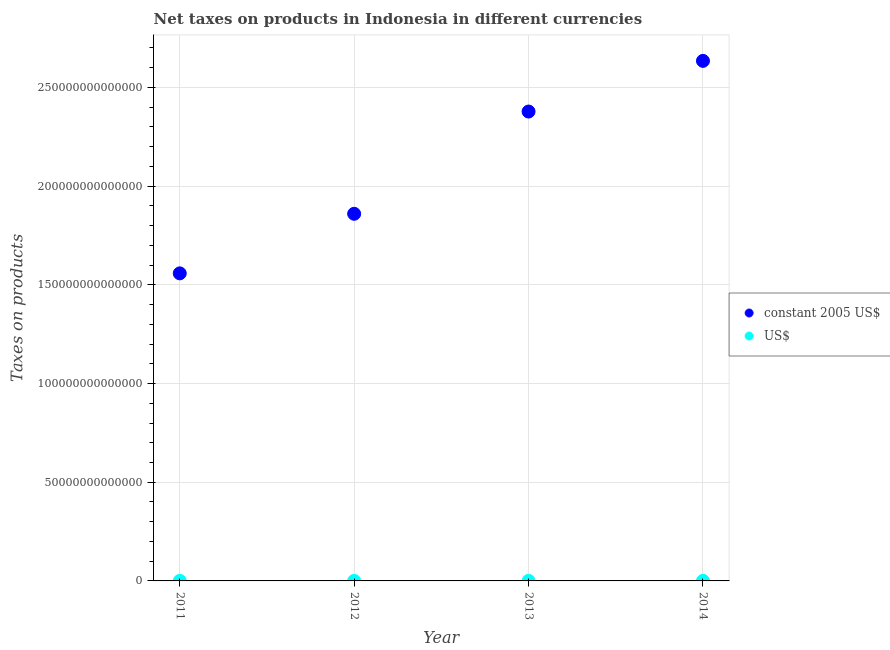How many different coloured dotlines are there?
Your answer should be very brief. 2. What is the net taxes in us$ in 2012?
Provide a short and direct response. 1.98e+1. Across all years, what is the maximum net taxes in constant 2005 us$?
Offer a very short reply. 2.63e+14. Across all years, what is the minimum net taxes in constant 2005 us$?
Give a very brief answer. 1.56e+14. In which year was the net taxes in us$ maximum?
Make the answer very short. 2013. What is the total net taxes in constant 2005 us$ in the graph?
Give a very brief answer. 8.43e+14. What is the difference between the net taxes in us$ in 2013 and that in 2014?
Provide a succinct answer. 5.26e+08. What is the difference between the net taxes in constant 2005 us$ in 2014 and the net taxes in us$ in 2012?
Give a very brief answer. 2.63e+14. What is the average net taxes in us$ per year?
Make the answer very short. 2.06e+1. In the year 2012, what is the difference between the net taxes in us$ and net taxes in constant 2005 us$?
Ensure brevity in your answer.  -1.86e+14. In how many years, is the net taxes in constant 2005 us$ greater than 40000000000000 units?
Ensure brevity in your answer.  4. What is the ratio of the net taxes in us$ in 2013 to that in 2014?
Your response must be concise. 1.02. Is the difference between the net taxes in us$ in 2011 and 2013 greater than the difference between the net taxes in constant 2005 us$ in 2011 and 2013?
Keep it short and to the point. Yes. What is the difference between the highest and the second highest net taxes in constant 2005 us$?
Provide a short and direct response. 2.57e+13. What is the difference between the highest and the lowest net taxes in constant 2005 us$?
Your answer should be compact. 1.08e+14. In how many years, is the net taxes in constant 2005 us$ greater than the average net taxes in constant 2005 us$ taken over all years?
Your response must be concise. 2. Is the net taxes in us$ strictly greater than the net taxes in constant 2005 us$ over the years?
Ensure brevity in your answer.  No. How many dotlines are there?
Your answer should be compact. 2. What is the difference between two consecutive major ticks on the Y-axis?
Your answer should be compact. 5.00e+13. Are the values on the major ticks of Y-axis written in scientific E-notation?
Your response must be concise. No. Does the graph contain any zero values?
Make the answer very short. No. Where does the legend appear in the graph?
Give a very brief answer. Center right. How many legend labels are there?
Give a very brief answer. 2. What is the title of the graph?
Your answer should be very brief. Net taxes on products in Indonesia in different currencies. Does "Arms exports" appear as one of the legend labels in the graph?
Offer a very short reply. No. What is the label or title of the Y-axis?
Your response must be concise. Taxes on products. What is the Taxes on products in constant 2005 US$ in 2011?
Provide a short and direct response. 1.56e+14. What is the Taxes on products of US$ in 2011?
Your answer should be compact. 1.78e+1. What is the Taxes on products of constant 2005 US$ in 2012?
Offer a very short reply. 1.86e+14. What is the Taxes on products in US$ in 2012?
Your response must be concise. 1.98e+1. What is the Taxes on products in constant 2005 US$ in 2013?
Keep it short and to the point. 2.38e+14. What is the Taxes on products in US$ in 2013?
Provide a succinct answer. 2.27e+1. What is the Taxes on products of constant 2005 US$ in 2014?
Keep it short and to the point. 2.63e+14. What is the Taxes on products in US$ in 2014?
Provide a succinct answer. 2.22e+1. Across all years, what is the maximum Taxes on products of constant 2005 US$?
Your answer should be very brief. 2.63e+14. Across all years, what is the maximum Taxes on products in US$?
Offer a very short reply. 2.27e+1. Across all years, what is the minimum Taxes on products of constant 2005 US$?
Ensure brevity in your answer.  1.56e+14. Across all years, what is the minimum Taxes on products in US$?
Your answer should be compact. 1.78e+1. What is the total Taxes on products in constant 2005 US$ in the graph?
Provide a short and direct response. 8.43e+14. What is the total Taxes on products of US$ in the graph?
Provide a short and direct response. 8.25e+1. What is the difference between the Taxes on products of constant 2005 US$ in 2011 and that in 2012?
Provide a short and direct response. -3.02e+13. What is the difference between the Taxes on products in US$ in 2011 and that in 2012?
Ensure brevity in your answer.  -2.05e+09. What is the difference between the Taxes on products of constant 2005 US$ in 2011 and that in 2013?
Your response must be concise. -8.20e+13. What is the difference between the Taxes on products in US$ in 2011 and that in 2013?
Ensure brevity in your answer.  -4.96e+09. What is the difference between the Taxes on products of constant 2005 US$ in 2011 and that in 2014?
Your answer should be compact. -1.08e+14. What is the difference between the Taxes on products in US$ in 2011 and that in 2014?
Your answer should be compact. -4.44e+09. What is the difference between the Taxes on products of constant 2005 US$ in 2012 and that in 2013?
Make the answer very short. -5.18e+13. What is the difference between the Taxes on products of US$ in 2012 and that in 2013?
Give a very brief answer. -2.92e+09. What is the difference between the Taxes on products of constant 2005 US$ in 2012 and that in 2014?
Ensure brevity in your answer.  -7.75e+13. What is the difference between the Taxes on products of US$ in 2012 and that in 2014?
Your response must be concise. -2.39e+09. What is the difference between the Taxes on products of constant 2005 US$ in 2013 and that in 2014?
Give a very brief answer. -2.57e+13. What is the difference between the Taxes on products in US$ in 2013 and that in 2014?
Your response must be concise. 5.26e+08. What is the difference between the Taxes on products in constant 2005 US$ in 2011 and the Taxes on products in US$ in 2012?
Provide a short and direct response. 1.56e+14. What is the difference between the Taxes on products of constant 2005 US$ in 2011 and the Taxes on products of US$ in 2013?
Keep it short and to the point. 1.56e+14. What is the difference between the Taxes on products of constant 2005 US$ in 2011 and the Taxes on products of US$ in 2014?
Provide a succinct answer. 1.56e+14. What is the difference between the Taxes on products in constant 2005 US$ in 2012 and the Taxes on products in US$ in 2013?
Your response must be concise. 1.86e+14. What is the difference between the Taxes on products in constant 2005 US$ in 2012 and the Taxes on products in US$ in 2014?
Your answer should be compact. 1.86e+14. What is the difference between the Taxes on products of constant 2005 US$ in 2013 and the Taxes on products of US$ in 2014?
Your answer should be very brief. 2.38e+14. What is the average Taxes on products in constant 2005 US$ per year?
Keep it short and to the point. 2.11e+14. What is the average Taxes on products of US$ per year?
Provide a short and direct response. 2.06e+1. In the year 2011, what is the difference between the Taxes on products of constant 2005 US$ and Taxes on products of US$?
Your response must be concise. 1.56e+14. In the year 2012, what is the difference between the Taxes on products in constant 2005 US$ and Taxes on products in US$?
Provide a succinct answer. 1.86e+14. In the year 2013, what is the difference between the Taxes on products of constant 2005 US$ and Taxes on products of US$?
Your answer should be compact. 2.38e+14. In the year 2014, what is the difference between the Taxes on products of constant 2005 US$ and Taxes on products of US$?
Give a very brief answer. 2.63e+14. What is the ratio of the Taxes on products of constant 2005 US$ in 2011 to that in 2012?
Make the answer very short. 0.84. What is the ratio of the Taxes on products of US$ in 2011 to that in 2012?
Offer a very short reply. 0.9. What is the ratio of the Taxes on products of constant 2005 US$ in 2011 to that in 2013?
Your response must be concise. 0.66. What is the ratio of the Taxes on products in US$ in 2011 to that in 2013?
Give a very brief answer. 0.78. What is the ratio of the Taxes on products in constant 2005 US$ in 2011 to that in 2014?
Your response must be concise. 0.59. What is the ratio of the Taxes on products in US$ in 2011 to that in 2014?
Your answer should be compact. 0.8. What is the ratio of the Taxes on products of constant 2005 US$ in 2012 to that in 2013?
Ensure brevity in your answer.  0.78. What is the ratio of the Taxes on products in US$ in 2012 to that in 2013?
Provide a short and direct response. 0.87. What is the ratio of the Taxes on products in constant 2005 US$ in 2012 to that in 2014?
Your answer should be very brief. 0.71. What is the ratio of the Taxes on products in US$ in 2012 to that in 2014?
Your response must be concise. 0.89. What is the ratio of the Taxes on products of constant 2005 US$ in 2013 to that in 2014?
Give a very brief answer. 0.9. What is the ratio of the Taxes on products in US$ in 2013 to that in 2014?
Your response must be concise. 1.02. What is the difference between the highest and the second highest Taxes on products in constant 2005 US$?
Provide a succinct answer. 2.57e+13. What is the difference between the highest and the second highest Taxes on products in US$?
Provide a short and direct response. 5.26e+08. What is the difference between the highest and the lowest Taxes on products in constant 2005 US$?
Your answer should be compact. 1.08e+14. What is the difference between the highest and the lowest Taxes on products in US$?
Provide a succinct answer. 4.96e+09. 